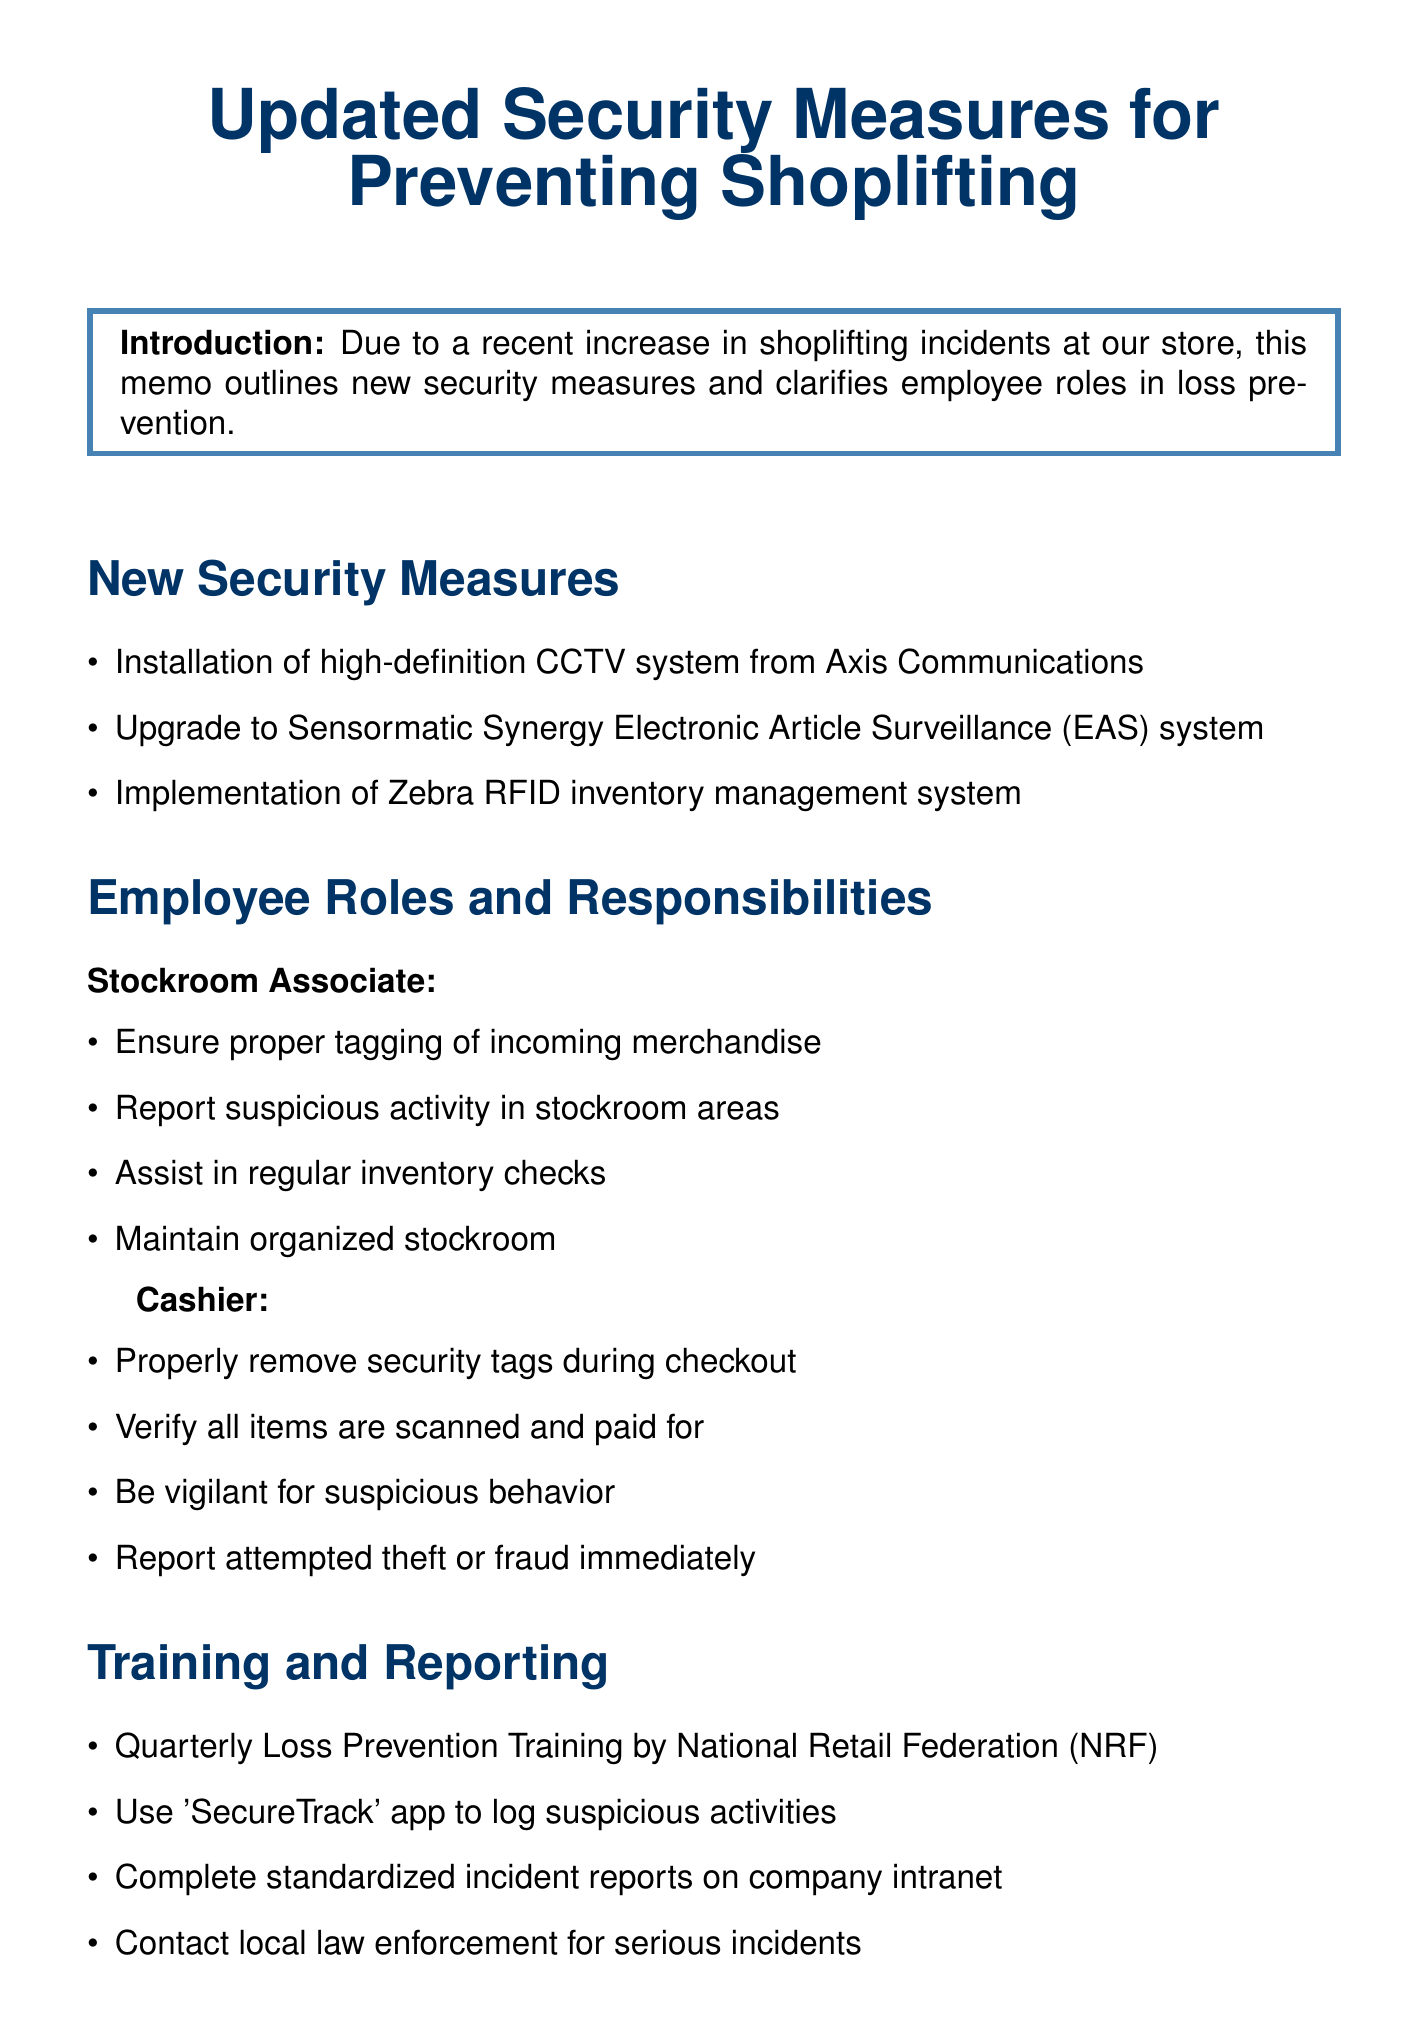What is the title of the memo? The title is the main heading that states the topic of the memo.
Answer: Updated Security Measures for Preventing Shoplifting Who installed the new CCTV system? The document specifies the company responsible for the installation of the new CCTV system.
Answer: Axis Communications What technology was implemented for inventory management? This question asks for the system introduced for tracking inventory in real-time.
Answer: Zebra RFID inventory management system How often is the Loss Prevention Training conducted? The frequency of the training program is mentioned in the document.
Answer: Quarterly What app is used for logging suspicious activities? The memo identifies a mobile application for reporting suspicious incidents.
Answer: SecureTrack What role has responsibilities for maintaining an organized stockroom? This question pertains to the specific employee role mentioned in relation to stockroom duties.
Answer: Stockroom Associate Which department does the memo encourage collaboration between? The document describes inter-departmental communication to enhance security measures.
Answer: Stockroom, sales floor, and cashier teams What is the contact extension for the Loss Prevention Supervisor? A specific extension number for contacting the Loss Prevention Supervisor is provided.
Answer: 5678 What is one of the key indicators for performance metrics? This question refers to measurable outcomes used to assess security performance in the store.
Answer: Monthly shrinkage rates 